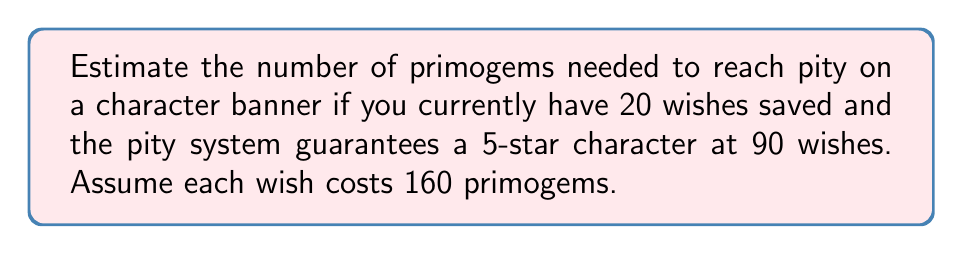Teach me how to tackle this problem. Let's break this down step-by-step:

1. First, we need to calculate how many more wishes are needed to reach pity:
   $$ \text{Wishes needed} = 90 - 20 = 70 \text{ wishes} $$

2. Now, we need to convert wishes to primogems. Each wish costs 160 primogems:
   $$ \text{Primogems per wish} = 160 $$

3. To calculate the total primogems needed, we multiply the number of wishes by the cost per wish:
   $$ \text{Total primogems} = 70 \times 160 = 11,200 \text{ primogems} $$

4. Since we're estimating, we can round this to a nearby thousand:
   $$ \text{Estimated primogems} \approx 11,000 \text{ primogems} $$

This estimation makes it easier to remember and plan for your primogem savings without being overly precise.
Answer: $11,000$ primogems 